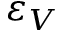<formula> <loc_0><loc_0><loc_500><loc_500>\varepsilon _ { V }</formula> 